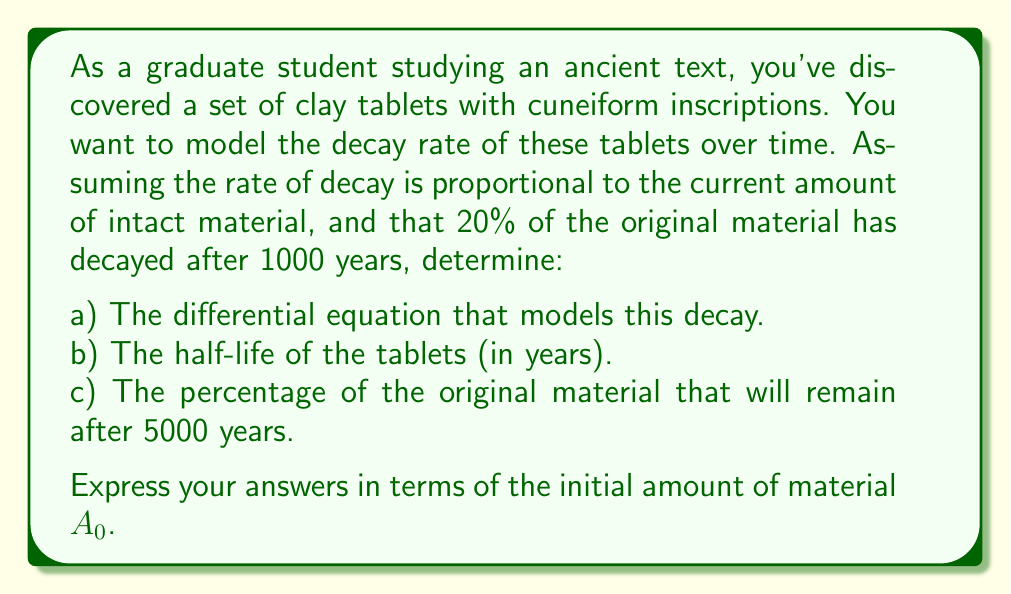Show me your answer to this math problem. Let's approach this step-by-step:

1) First, we need to set up the differential equation. Let $A(t)$ be the amount of intact material at time $t$. The rate of decay is proportional to the current amount, so:

   $$\frac{dA}{dt} = -kA$$

   where $k$ is the decay constant.

2) The solution to this differential equation is:

   $$A(t) = A_0e^{-kt}$$

   where $A_0$ is the initial amount of material.

3) We're told that 20% has decayed after 1000 years, so 80% remains. We can use this to find $k$:

   $$0.8A_0 = A_0e^{-k(1000)}$$
   $$0.8 = e^{-1000k}$$
   $$\ln(0.8) = -1000k$$
   $$k = -\frac{\ln(0.8)}{1000} \approx 2.231 \times 10^{-4}$$

4) For the half-life $t_{1/2}$, we want:

   $$\frac{1}{2}A_0 = A_0e^{-kt_{1/2}}$$
   $$\frac{1}{2} = e^{-kt_{1/2}}$$
   $$\ln(\frac{1}{2}) = -kt_{1/2}$$
   $$t_{1/2} = \frac{\ln(2)}{k} = \frac{1000\ln(2)}{\ln(0.8)^{-1}} \approx 3106.8 \text{ years}$$

5) For the percentage remaining after 5000 years:

   $$\frac{A(5000)}{A_0} = e^{-k(5000)} = e^{5\ln(0.8)} = (0.8)^5 \approx 0.32768$$

   So approximately 32.768% will remain.
Answer: a) $\frac{dA}{dt} = -kA$, where $k = -\frac{\ln(0.8)}{1000}$
b) $t_{1/2} = \frac{1000\ln(2)}{\ln(0.8)^{-1}} \approx 3106.8$ years
c) $32.768\%$ 